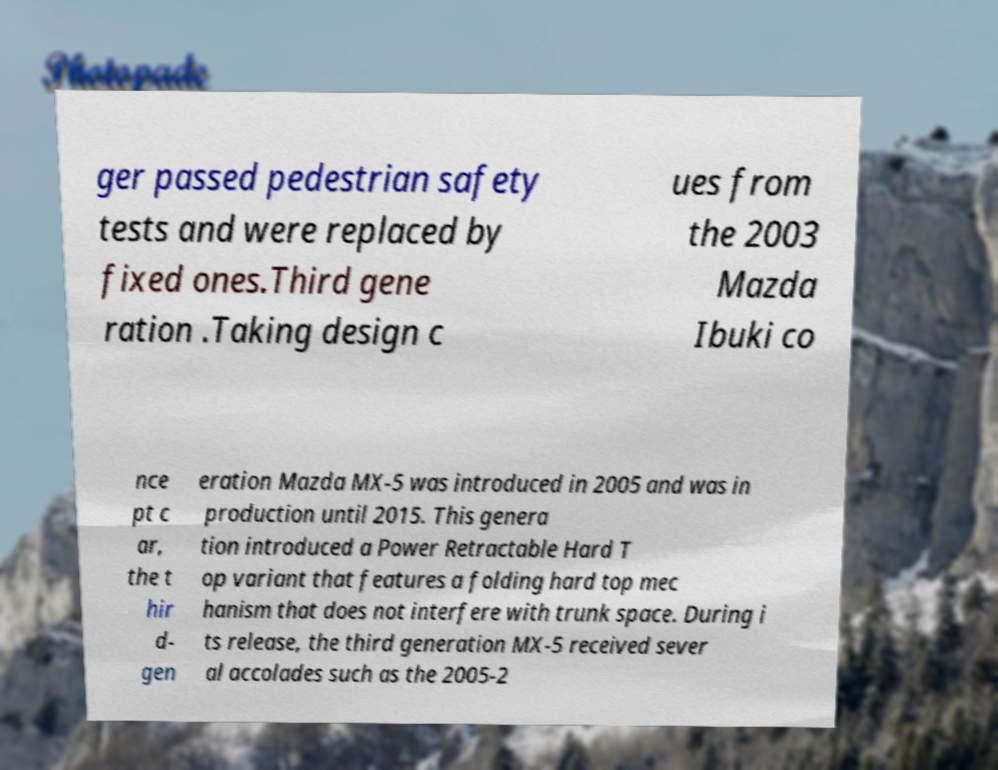Please read and relay the text visible in this image. What does it say? ger passed pedestrian safety tests and were replaced by fixed ones.Third gene ration .Taking design c ues from the 2003 Mazda Ibuki co nce pt c ar, the t hir d- gen eration Mazda MX-5 was introduced in 2005 and was in production until 2015. This genera tion introduced a Power Retractable Hard T op variant that features a folding hard top mec hanism that does not interfere with trunk space. During i ts release, the third generation MX-5 received sever al accolades such as the 2005-2 